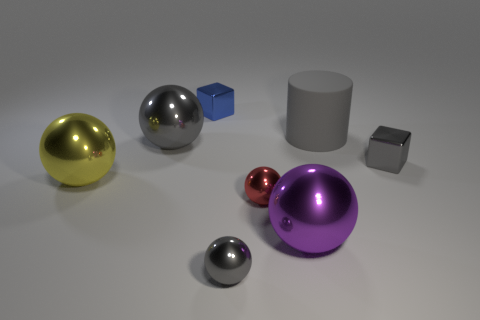Subtract all purple balls. How many balls are left? 4 Subtract all purple spheres. How many spheres are left? 4 Subtract all blue balls. Subtract all green cubes. How many balls are left? 5 Add 2 large yellow things. How many objects exist? 10 Subtract all blocks. How many objects are left? 6 Add 7 big purple metallic balls. How many big purple metallic balls are left? 8 Add 1 gray matte blocks. How many gray matte blocks exist? 1 Subtract 0 yellow cubes. How many objects are left? 8 Subtract all red things. Subtract all small metal things. How many objects are left? 3 